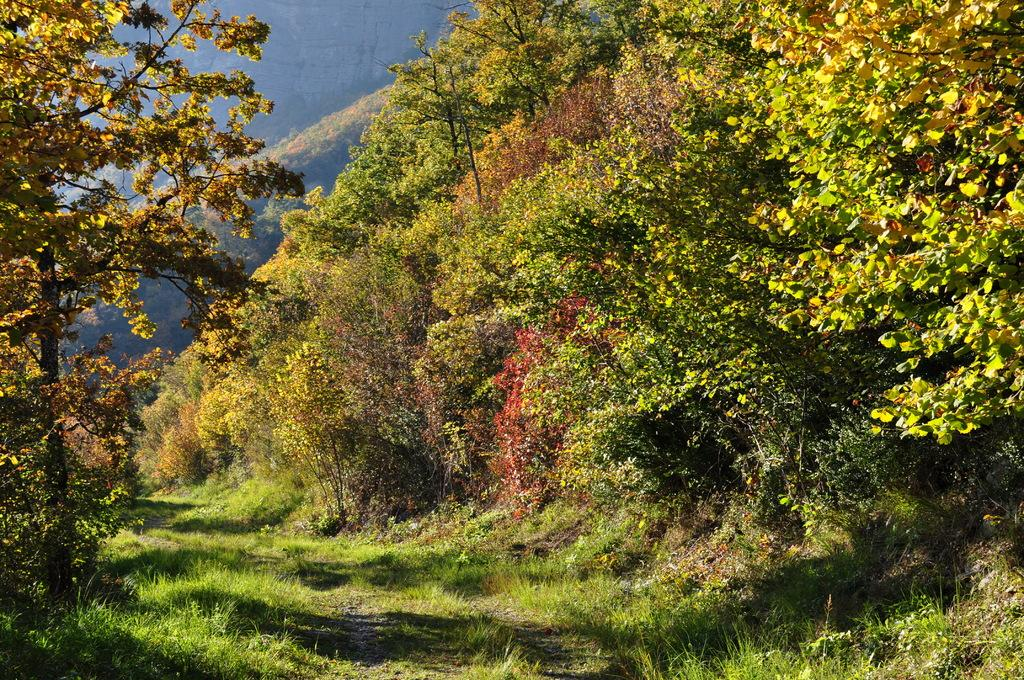What type of vegetation can be seen on the right side of the image? There are trees on the right side of the image. What type of vegetation can be seen on the left side of the image? There are trees on the left side of the image. What type of ground cover is visible at the bottom of the image? There is grass at the bottom of the image. What can be seen in the background of the image? There is a group of trees in the background of the image. What type of chair is visible in the image? There is no chair present in the image. What type of trail can be seen in the image? There is no trail present in the image. 